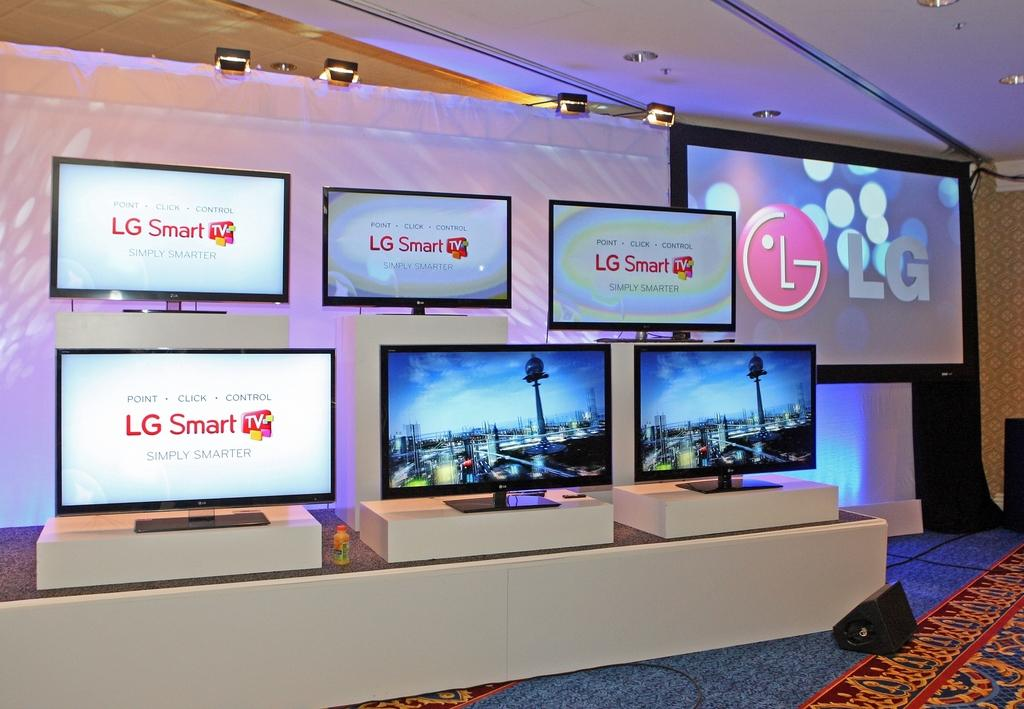Provide a one-sentence caption for the provided image. A display of six LG Smart tv's and one large screen LG tv. 